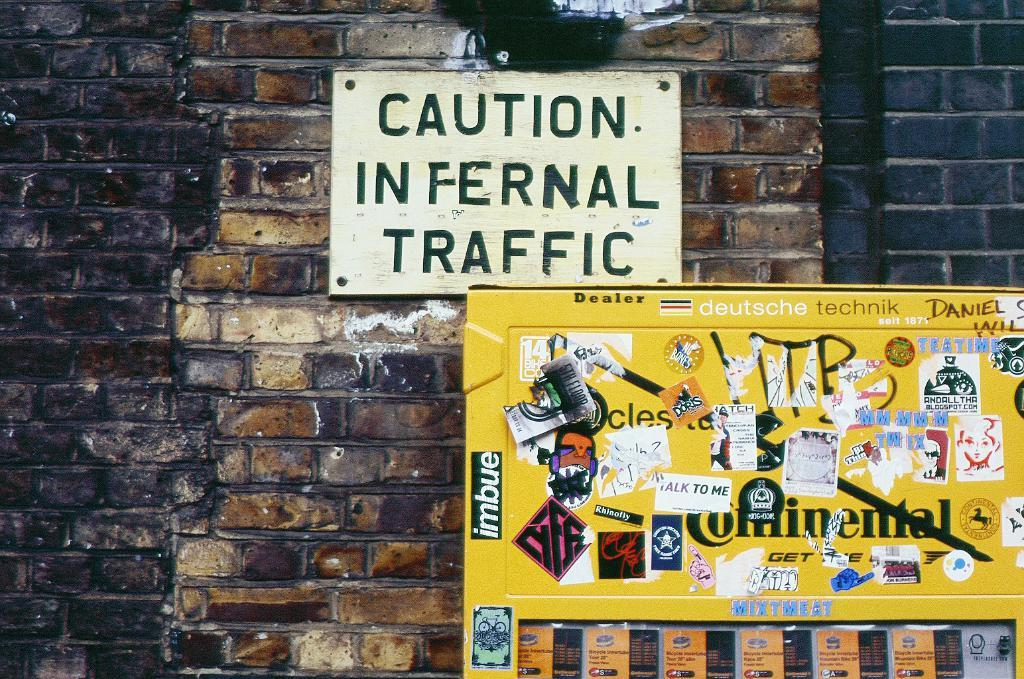What type of structure is visible in the image? There is a brick wall in the image. What can be seen in front of the brick wall? There are two objects in front of the wall. Can you describe one of the objects? One of the objects looks like a frame. What is written or displayed on the frame? The frame has text on it. How does the actor interact with the nerve in the image? There is no actor or nerve present in the image; it features a brick wall and two objects, one of which is a frame with text. 